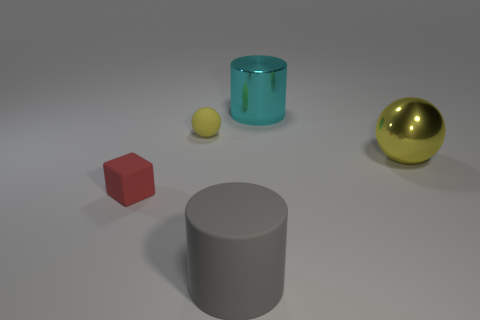Are there more gray matte things on the right side of the tiny red block than big green matte cylinders?
Your response must be concise. Yes. What number of objects are either yellow metal balls or small matte things?
Provide a succinct answer. 3. The large matte cylinder is what color?
Give a very brief answer. Gray. What number of other things are there of the same color as the metallic ball?
Offer a very short reply. 1. Are there any large objects left of the cyan metallic object?
Make the answer very short. Yes. There is a object that is right of the metallic thing that is behind the sphere that is on the left side of the big matte object; what is its color?
Offer a very short reply. Yellow. What number of large cylinders are behind the yellow metallic sphere and in front of the large cyan shiny thing?
Your response must be concise. 0. How many cylinders are either purple matte things or big gray matte objects?
Make the answer very short. 1. Is there a yellow metallic thing?
Keep it short and to the point. Yes. How many other objects are the same material as the cube?
Your response must be concise. 2. 